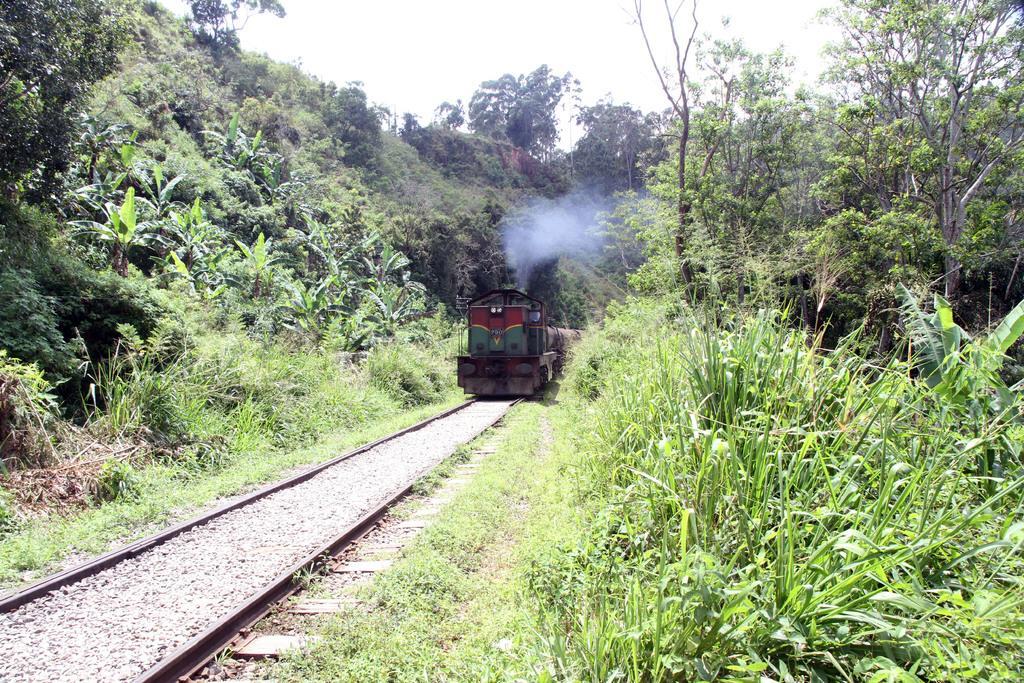Could you give a brief overview of what you see in this image? in this image we can see a train on the railway track, trees, grass and sky. 